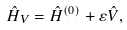<formula> <loc_0><loc_0><loc_500><loc_500>\hat { H } _ { V } = \hat { H } ^ { ( 0 ) } + \varepsilon { \hat { V } } ,</formula> 